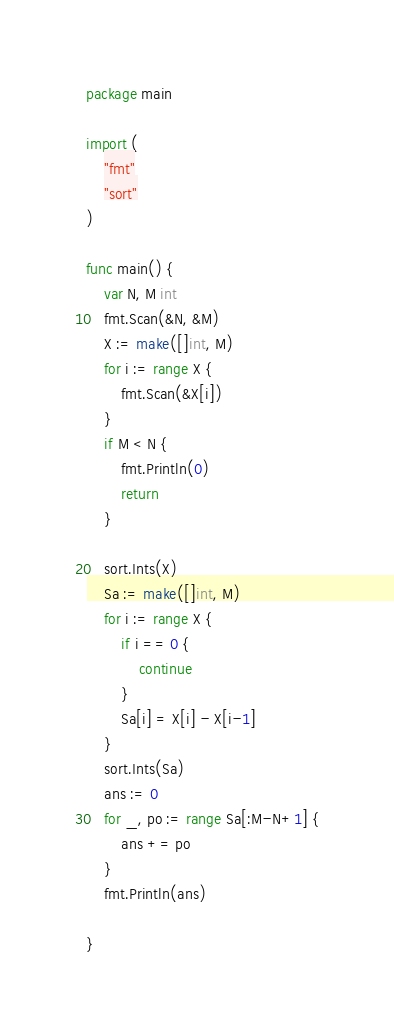<code> <loc_0><loc_0><loc_500><loc_500><_Go_>package main

import (
	"fmt"
	"sort"
)

func main() {
	var N, M int
	fmt.Scan(&N, &M)
	X := make([]int, M)
	for i := range X {
		fmt.Scan(&X[i])
	}
	if M < N {
		fmt.Println(0)
		return
	}

	sort.Ints(X)
	Sa := make([]int, M)
	for i := range X {
		if i == 0 {
			continue
		}
		Sa[i] = X[i] - X[i-1]
	}
	sort.Ints(Sa)
	ans := 0
	for _, po := range Sa[:M-N+1] {
		ans += po
	}
	fmt.Println(ans)

}
</code> 